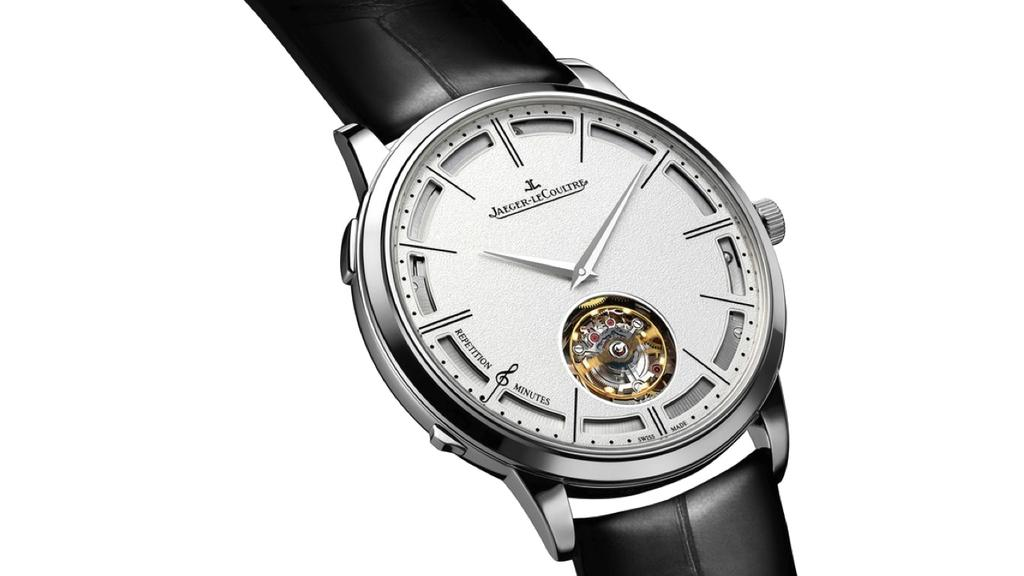<image>
Give a short and clear explanation of the subsequent image. A Jaeger-LeCoultre watch has a window showing the gold movement inside. 